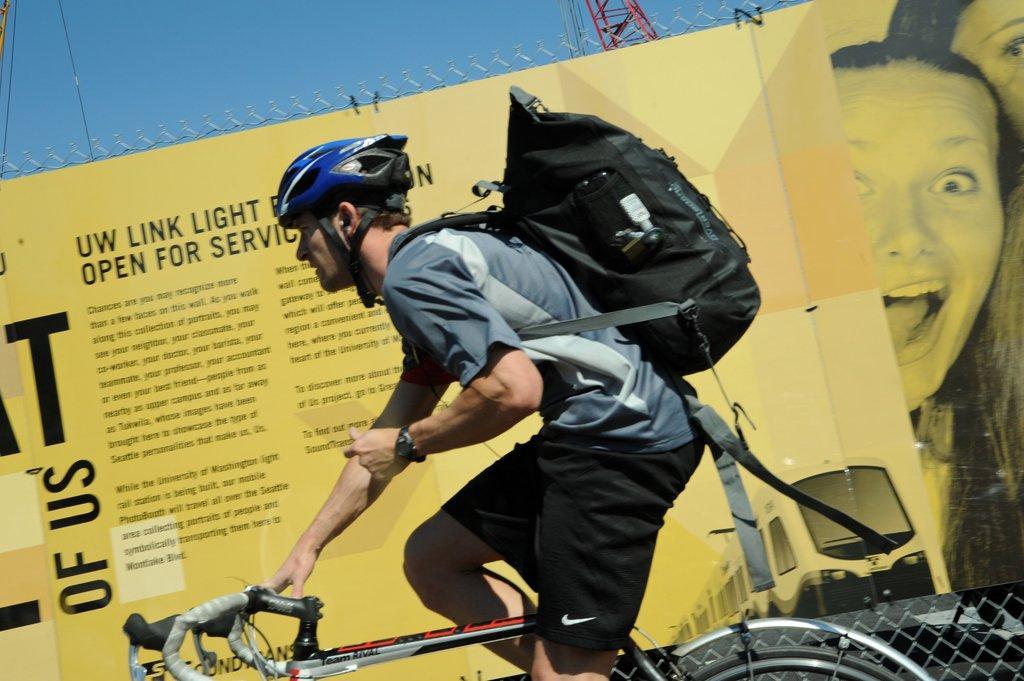Please provide a concise description of this image. In the center we can see one man riding cycle,he is carrying backpack. And back there is a banner, sky etc. 